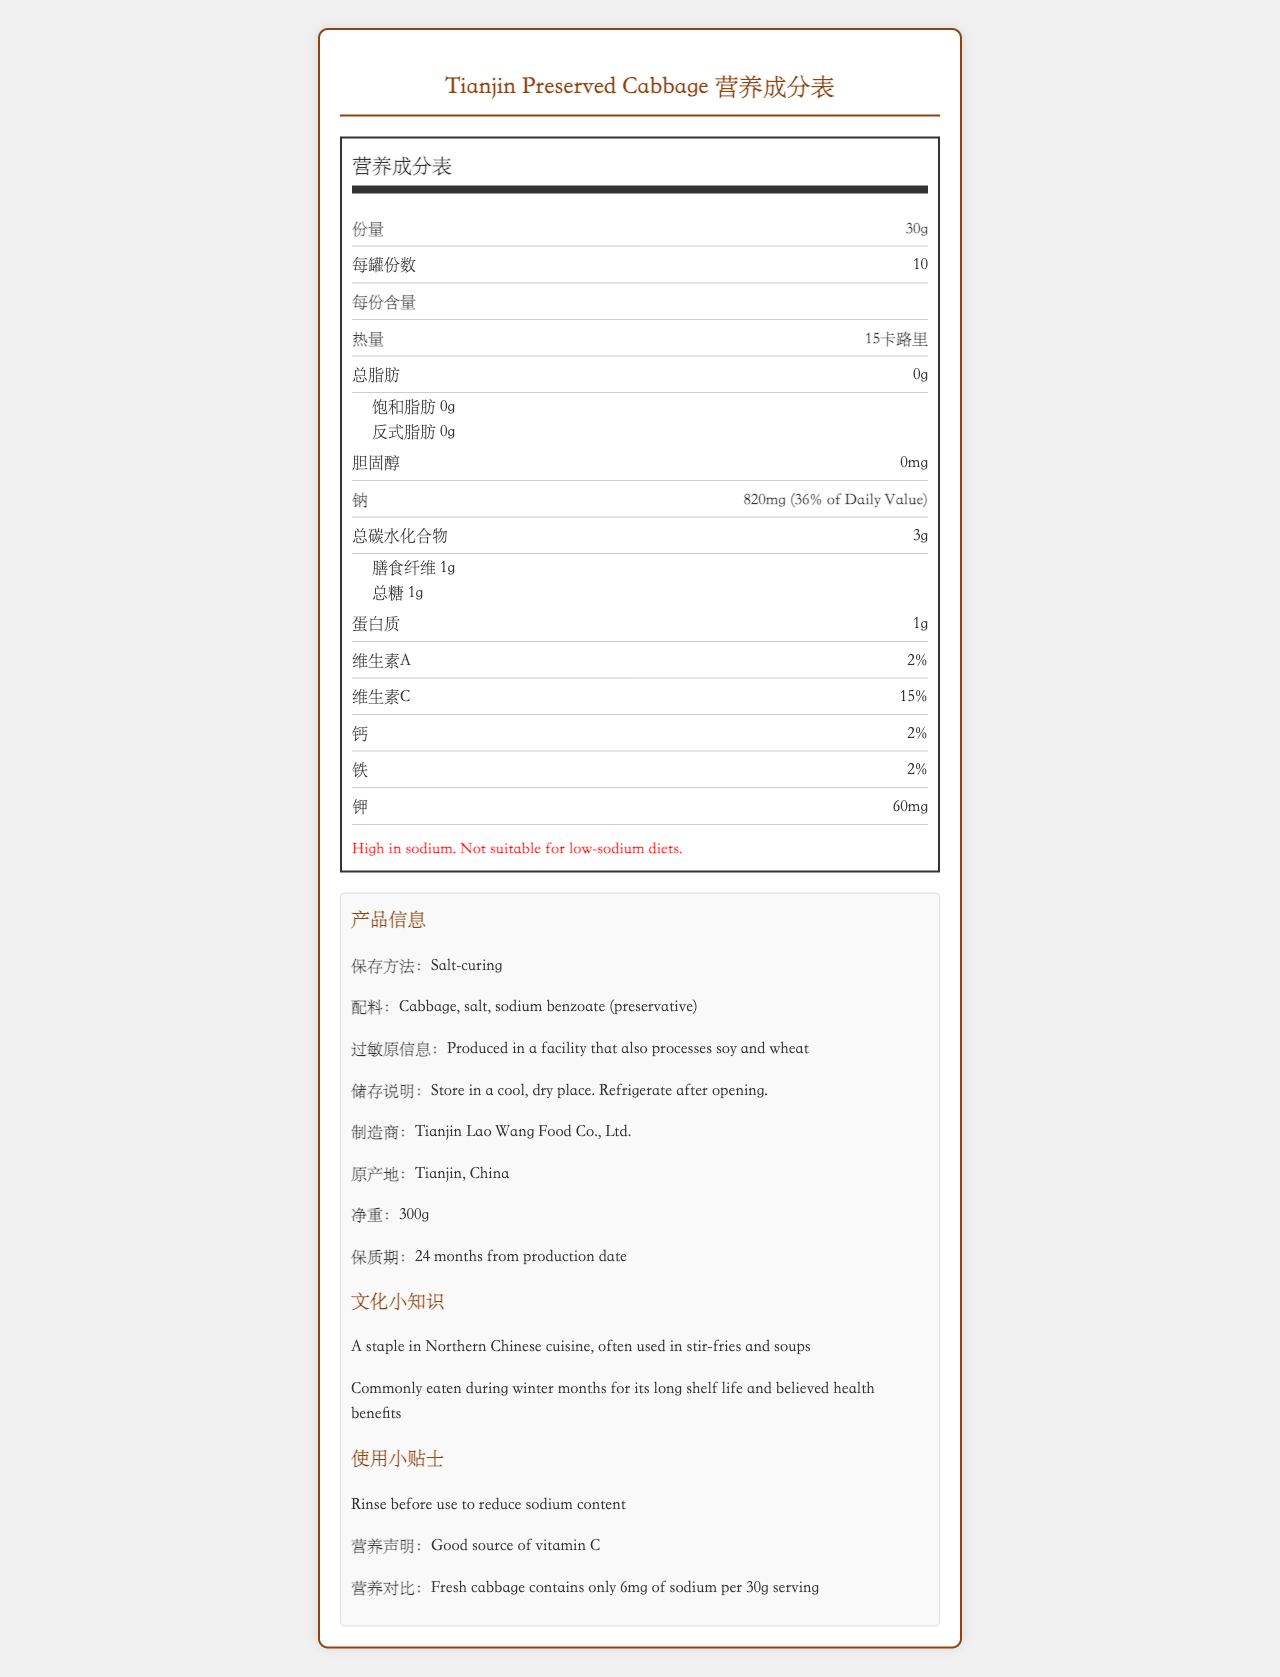How much sodium is in one serving of Tianjin Preserved Cabbage? The Nutrition Facts Label clearly states that there are 820 mg of sodium per 30g serving.
Answer: 820 mg What is the preservation method used for Tianjin Preserved Cabbage? The document specifies that the preservation method is "Salt-curing" listed under product information.
Answer: Salt-curing How many servings are there per container? The Nutrition Facts Label indicates that there are 10 servings per container.
Answer: 10 What is the serving size of Tianjin Preserved Cabbage? The document states the serving size as "30g" in the Nutrition Facts section.
Answer: 30g What is the recommended storage condition after opening the container? The storage instructions mention to "Refrigerate after opening."
Answer: Refrigerate Which vitamin is Tianjin Preserved Cabbage a good source of? A. Vitamin A B. Vitamin C C. Calcium D. Iron The nutritional claim in the document states that Tianjin Preserved Cabbage is a good source of vitamin C.
Answer: B What is the percentage of Daily Value for sodium in one serving? A. 10% B. 20% C. 36% D. 50% The Nutrition Facts Label indicates that the sodium content is 36% of the Daily Value.
Answer: C Is Tianjin Preserved Cabbage suitable for low-sodium diets? The document includes a sodium warning stating that it is high in sodium and not suitable for low-sodium diets.
Answer: No Describe the main nutritional highlights and additional information about Tianjin Preserved Cabbage. The document discusses the nutrition facts, preservation method, storage instructions, ingredients, allergen information, and cultural notes about Tianjin Preserved Cabbage.
Answer: Tianjin Preserved Cabbage has a high sodium content of 820 mg per serving, which is 36% of the Daily Value. It contains 15 calories per serving and negligible fat, cholesterol, and protein. It is preserved using salt-curing and includes ingredients like cabbage, salt, and sodium benzoate. It should be stored in a cool, dry place and refrigerated after opening. How does the sodium content of Tianjin Preserved Cabbage compare to that of fresh cabbage? The document states that fresh cabbage contains only 6 mg of sodium per 30g serving, while Tianjin Preserved Cabbage contains 820 mg.
Answer: Tianjin Preserved Cabbage contains significantly more sodium than fresh cabbage. How is Tianjin Preserved Cabbage traditionally used in Northern Chinese cuisine? The document mentions that it is a staple in Northern Chinese cuisine and is often used in stir-fries and soups.
Answer: Often used in stir-fries and soups What is the expiration date of Tianjin Preserved Cabbage from the production date? The document states that the expiration date is 24 months from the production date.
Answer: 24 months In what facility condition is Tianjin Preserved Cabbage produced concerning allergens? The allergen information indicates that the product is produced in a facility that also processes soy and wheat.
Answer: In a facility that also processes soy and wheat What is the total carbohydrate content in one serving of Tianjin Preserved Cabbage? The Nutrition Facts Label lists the total carbohydrate content as 3g per serving.
Answer: 3g Did the Nutrition Facts Label mention any health benefits of Tianjin Preserved Cabbage associated with its long shelf life? The traditional uses state that it is commonly eaten during the winter months for its long shelf life and believed health benefits.
Answer: Yes What are the traditional months in which Tianjin Preserved Cabbage is commonly consumed? The document discusses that it is commonly eaten during the winter months due to its long shelf life.
Answer: During the winter months What type of document format is used to display the Nutrition Facts Label in the explanation provided? The document does not provide details on the specific format or code used to generate the Nutrition Facts Label.
Answer: Not enough information 